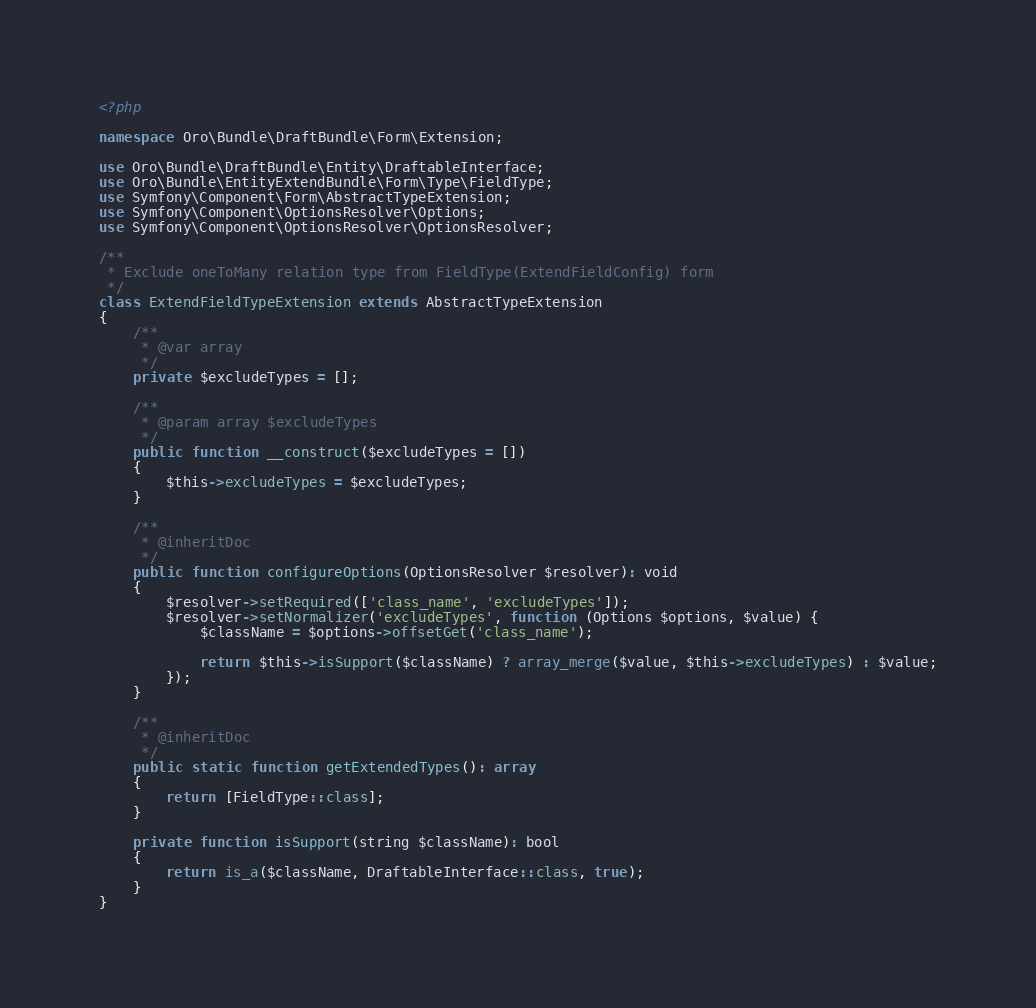<code> <loc_0><loc_0><loc_500><loc_500><_PHP_><?php

namespace Oro\Bundle\DraftBundle\Form\Extension;

use Oro\Bundle\DraftBundle\Entity\DraftableInterface;
use Oro\Bundle\EntityExtendBundle\Form\Type\FieldType;
use Symfony\Component\Form\AbstractTypeExtension;
use Symfony\Component\OptionsResolver\Options;
use Symfony\Component\OptionsResolver\OptionsResolver;

/**
 * Exclude oneToMany relation type from FieldType(ExtendFieldConfig) form
 */
class ExtendFieldTypeExtension extends AbstractTypeExtension
{
    /**
     * @var array
     */
    private $excludeTypes = [];

    /**
     * @param array $excludeTypes
     */
    public function __construct($excludeTypes = [])
    {
        $this->excludeTypes = $excludeTypes;
    }

    /**
     * @inheritDoc
     */
    public function configureOptions(OptionsResolver $resolver): void
    {
        $resolver->setRequired(['class_name', 'excludeTypes']);
        $resolver->setNormalizer('excludeTypes', function (Options $options, $value) {
            $className = $options->offsetGet('class_name');

            return $this->isSupport($className) ? array_merge($value, $this->excludeTypes) : $value;
        });
    }

    /**
     * @inheritDoc
     */
    public static function getExtendedTypes(): array
    {
        return [FieldType::class];
    }

    private function isSupport(string $className): bool
    {
        return is_a($className, DraftableInterface::class, true);
    }
}
</code> 